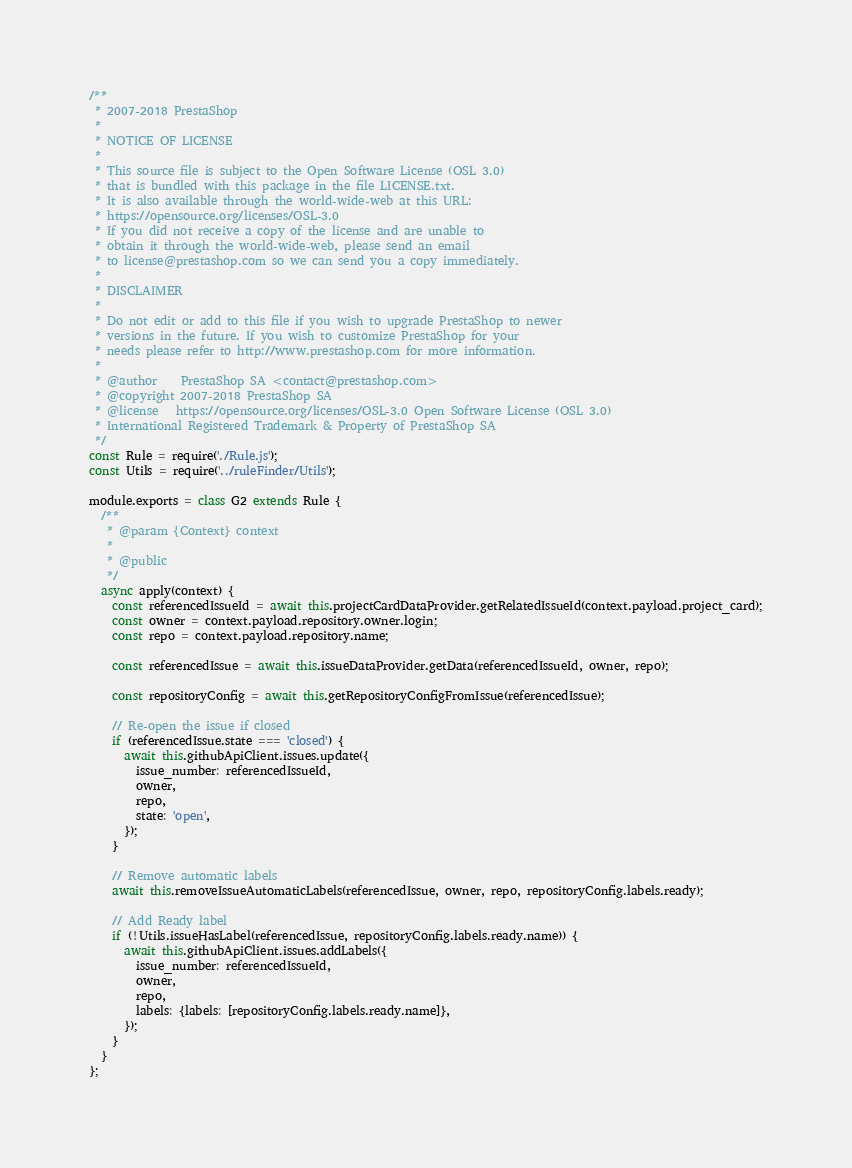Convert code to text. <code><loc_0><loc_0><loc_500><loc_500><_JavaScript_>/**
 * 2007-2018 PrestaShop
 *
 * NOTICE OF LICENSE
 *
 * This source file is subject to the Open Software License (OSL 3.0)
 * that is bundled with this package in the file LICENSE.txt.
 * It is also available through the world-wide-web at this URL:
 * https://opensource.org/licenses/OSL-3.0
 * If you did not receive a copy of the license and are unable to
 * obtain it through the world-wide-web, please send an email
 * to license@prestashop.com so we can send you a copy immediately.
 *
 * DISCLAIMER
 *
 * Do not edit or add to this file if you wish to upgrade PrestaShop to newer
 * versions in the future. If you wish to customize PrestaShop for your
 * needs please refer to http://www.prestashop.com for more information.
 *
 * @author    PrestaShop SA <contact@prestashop.com>
 * @copyright 2007-2018 PrestaShop SA
 * @license   https://opensource.org/licenses/OSL-3.0 Open Software License (OSL 3.0)
 * International Registered Trademark & Property of PrestaShop SA
 */
const Rule = require('./Rule.js');
const Utils = require('../ruleFinder/Utils');

module.exports = class G2 extends Rule {
  /**
   * @param {Context} context
   *
   * @public
   */
  async apply(context) {
    const referencedIssueId = await this.projectCardDataProvider.getRelatedIssueId(context.payload.project_card);
    const owner = context.payload.repository.owner.login;
    const repo = context.payload.repository.name;

    const referencedIssue = await this.issueDataProvider.getData(referencedIssueId, owner, repo);

    const repositoryConfig = await this.getRepositoryConfigFromIssue(referencedIssue);

    // Re-open the issue if closed
    if (referencedIssue.state === 'closed') {
      await this.githubApiClient.issues.update({
        issue_number: referencedIssueId,
        owner,
        repo,
        state: 'open',
      });
    }

    // Remove automatic labels
    await this.removeIssueAutomaticLabels(referencedIssue, owner, repo, repositoryConfig.labels.ready);

    // Add Ready label
    if (!Utils.issueHasLabel(referencedIssue, repositoryConfig.labels.ready.name)) {
      await this.githubApiClient.issues.addLabels({
        issue_number: referencedIssueId,
        owner,
        repo,
        labels: {labels: [repositoryConfig.labels.ready.name]},
      });
    }
  }
};
</code> 